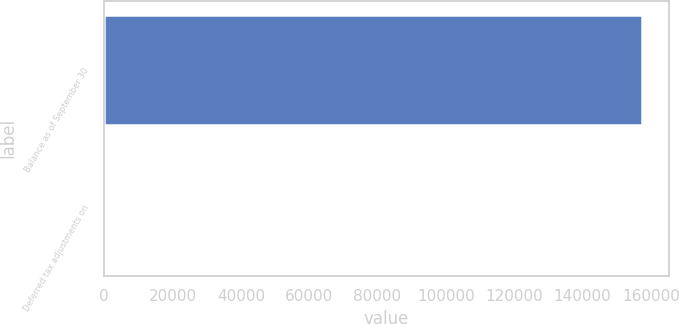<chart> <loc_0><loc_0><loc_500><loc_500><bar_chart><fcel>Balance as of September 30<fcel>Deferred tax adjustments on<nl><fcel>157313<fcel>40<nl></chart> 